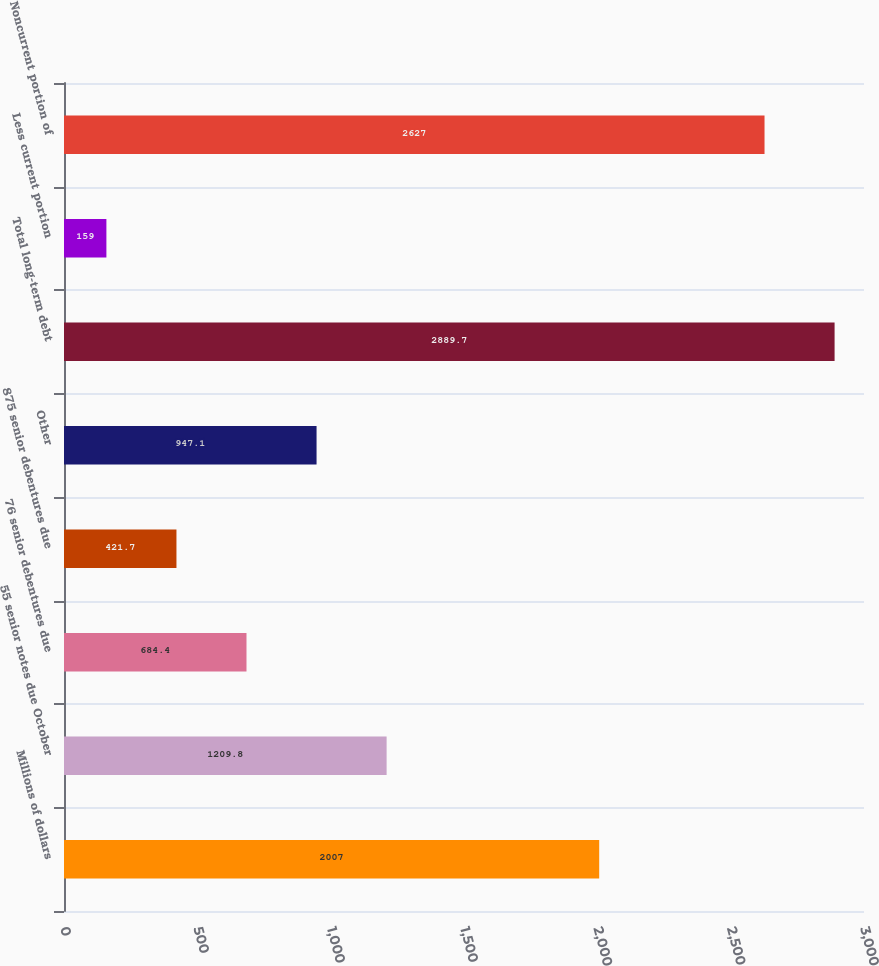Convert chart. <chart><loc_0><loc_0><loc_500><loc_500><bar_chart><fcel>Millions of dollars<fcel>55 senior notes due October<fcel>76 senior debentures due<fcel>875 senior debentures due<fcel>Other<fcel>Total long-term debt<fcel>Less current portion<fcel>Noncurrent portion of<nl><fcel>2007<fcel>1209.8<fcel>684.4<fcel>421.7<fcel>947.1<fcel>2889.7<fcel>159<fcel>2627<nl></chart> 